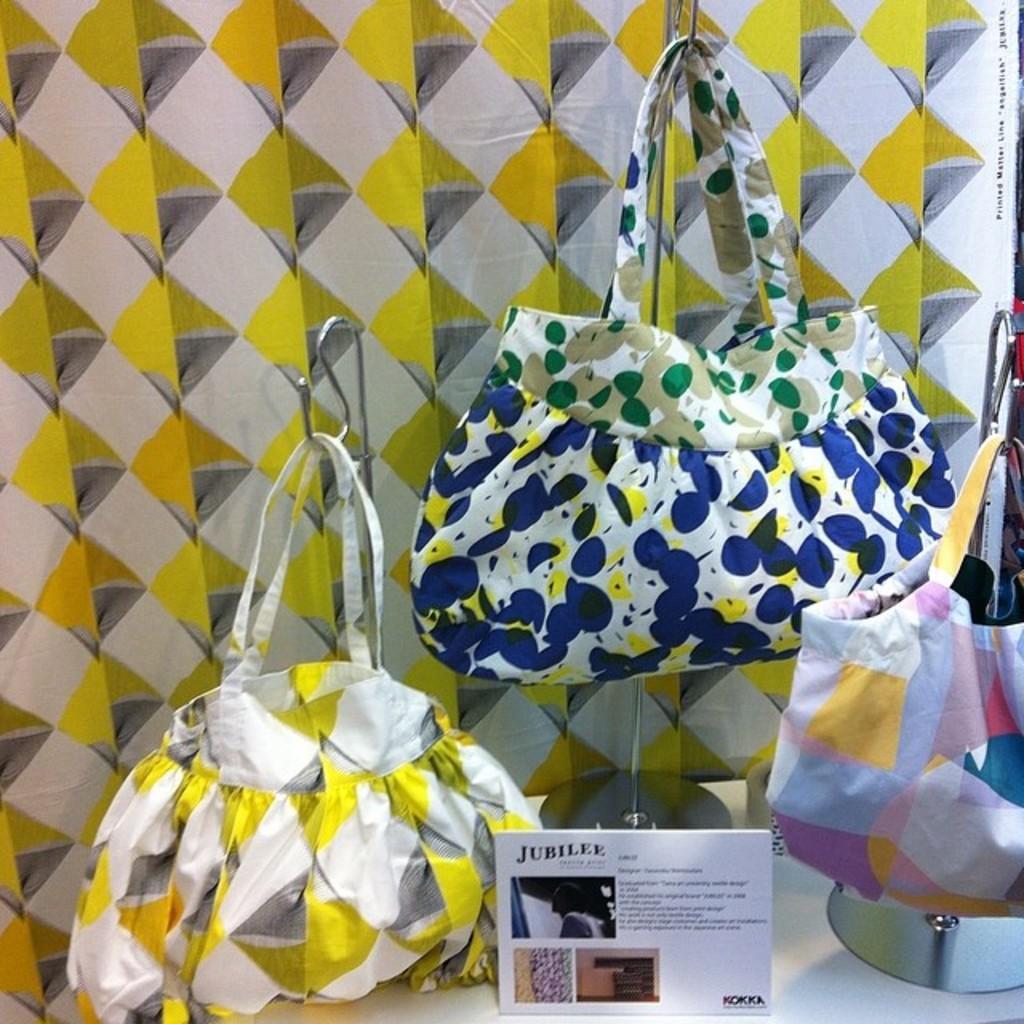Please provide a concise description of this image. In this picture, we see three handbags. Bag which is in white and yellow and grey color is placed on the left side of the picture and on the right side, we see bag which is in yellow, blue and pink color. In the middle of the picture, we see a bag which is in blue, white and green color. Behind these bag, we see a wall which is in yellow, white and grey color. 